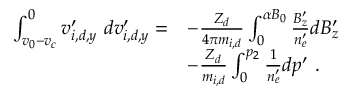Convert formula to latex. <formula><loc_0><loc_0><loc_500><loc_500>\begin{array} { r l } { \int _ { v _ { 0 } - v _ { c } } ^ { 0 } v _ { i , d , y } ^ { \prime } \ d v _ { i , d , y } ^ { \prime } = } & { - \frac { Z _ { d } } { 4 \pi m _ { i , d } } \int _ { 0 } ^ { \alpha B _ { 0 } } \frac { B _ { z } ^ { \prime } } { n _ { e } ^ { \prime } } d B _ { z } ^ { \prime } } \\ & { - \frac { Z _ { d } } { m _ { i , d } } \int _ { 0 } ^ { p _ { 2 } } \frac { 1 } { n _ { e } ^ { \prime } } d p ^ { \prime } \ . } \end{array}</formula> 